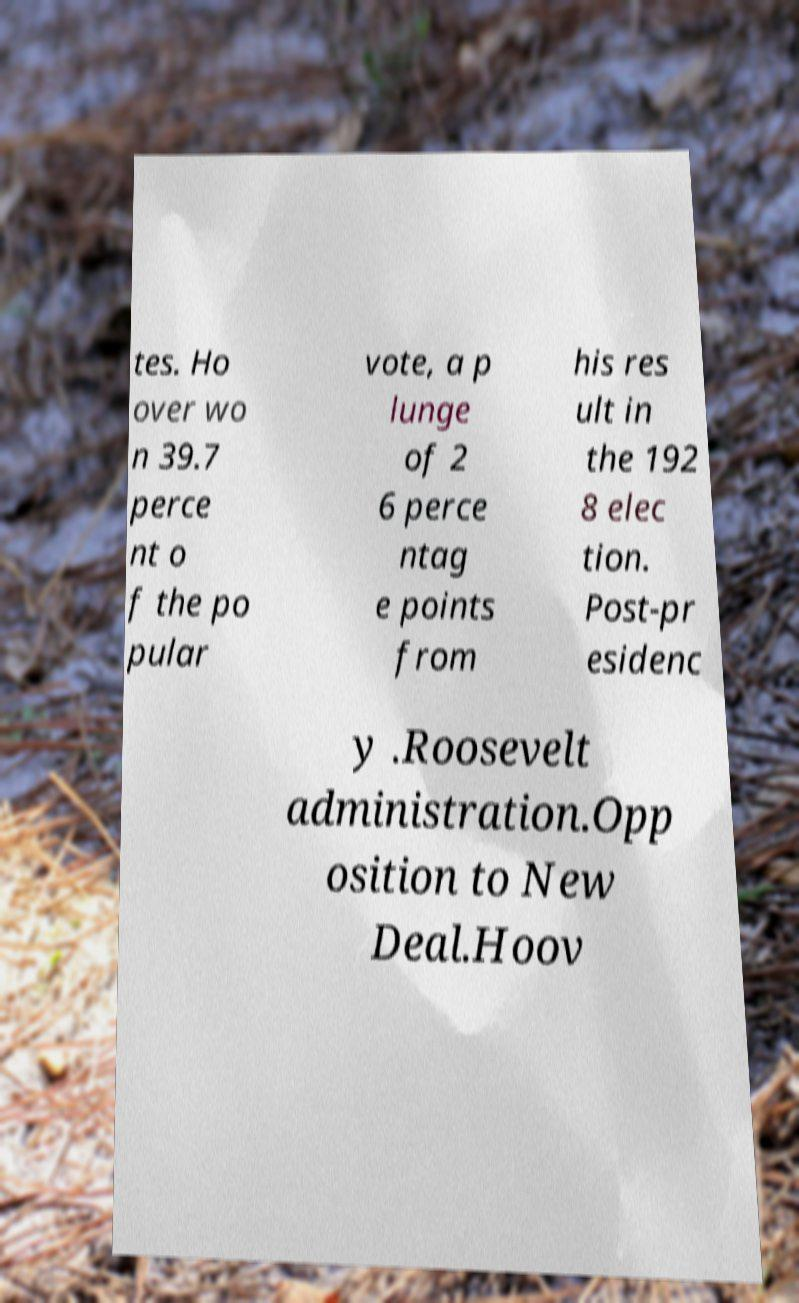I need the written content from this picture converted into text. Can you do that? tes. Ho over wo n 39.7 perce nt o f the po pular vote, a p lunge of 2 6 perce ntag e points from his res ult in the 192 8 elec tion. Post-pr esidenc y .Roosevelt administration.Opp osition to New Deal.Hoov 